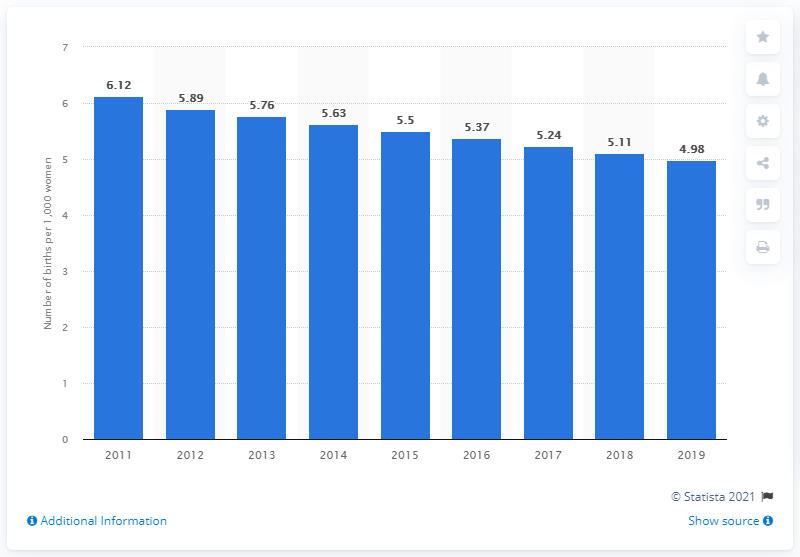List a handful of essential elements in this visual. In 2019, the birth rate per thousand women aged 15 to 19 years in Italy was 4.98. 